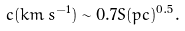<formula> <loc_0><loc_0><loc_500><loc_500>c ( k m \, s ^ { - 1 } ) \sim 0 . 7 S ( p c ) ^ { 0 . 5 } .</formula> 